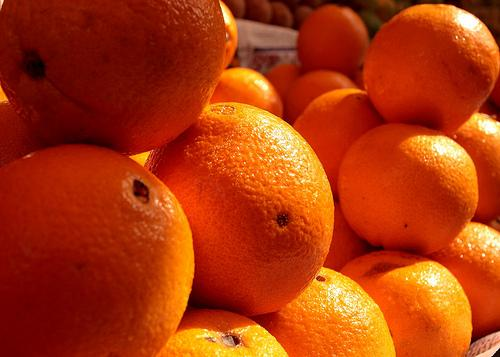What fruit is in the picture? oranges 